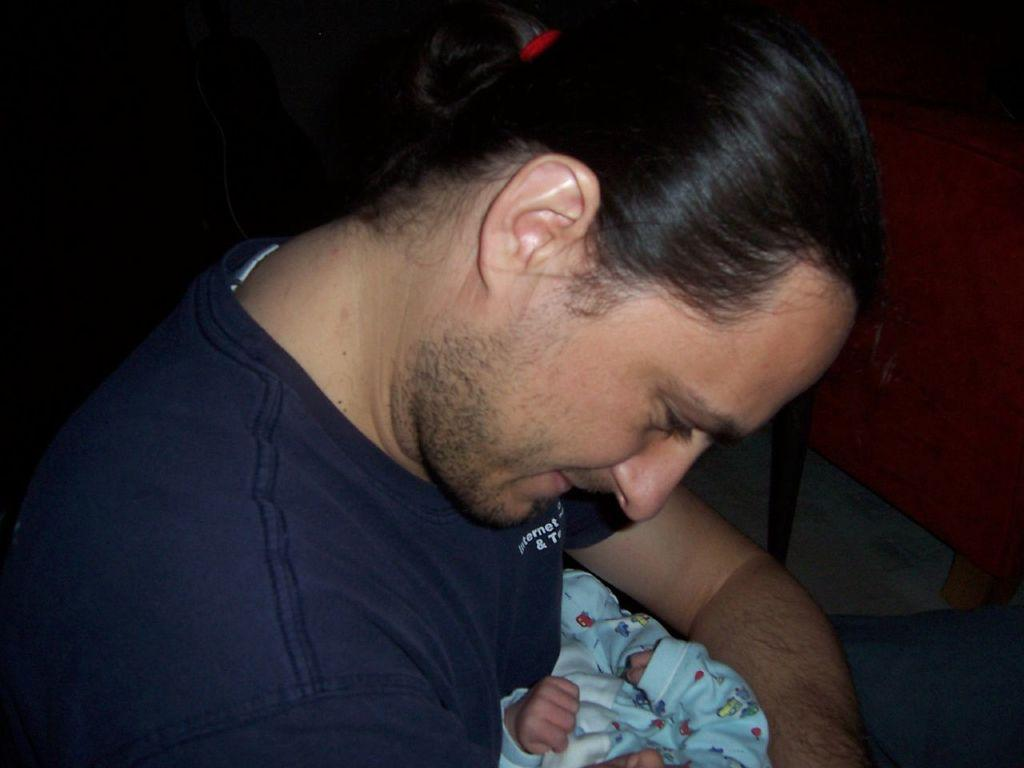What is the main subject of the image? There is a person in the image. What is the person wearing? The person is wearing a t-shirt. What is the person doing in the image? The person is holding a baby. What color is the couch in the image? The couch in the image is red. What color is the background of the image? The background of the image is black. What type of dirt can be seen on the person's shoes in the image? There is no dirt visible on the person's shoes in the image, nor are any shoes mentioned in the provided facts. 